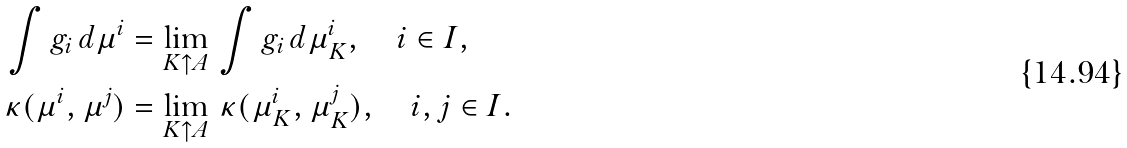<formula> <loc_0><loc_0><loc_500><loc_500>\int g _ { i } \, d \mu ^ { i } & = \lim _ { K \uparrow A } \, \int g _ { i } \, d \mu _ { K } ^ { i } , \quad i \in I , \\ \kappa ( \mu ^ { i } , \mu ^ { j } ) & = \lim _ { K \uparrow A } \, \kappa ( \mu _ { K } ^ { i } , \mu _ { K } ^ { j } ) , \quad i , j \in I .</formula> 